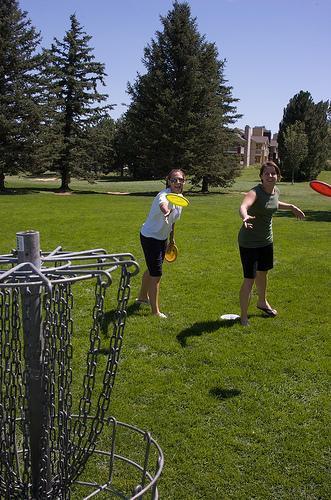How many people are in the picture?
Give a very brief answer. 2. How many wood chairs are tilted?
Give a very brief answer. 0. 